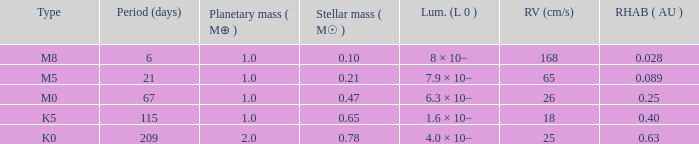What is the highest planetary mass having an RV (cm/s) of 65 and a Period (days) less than 21? None. 